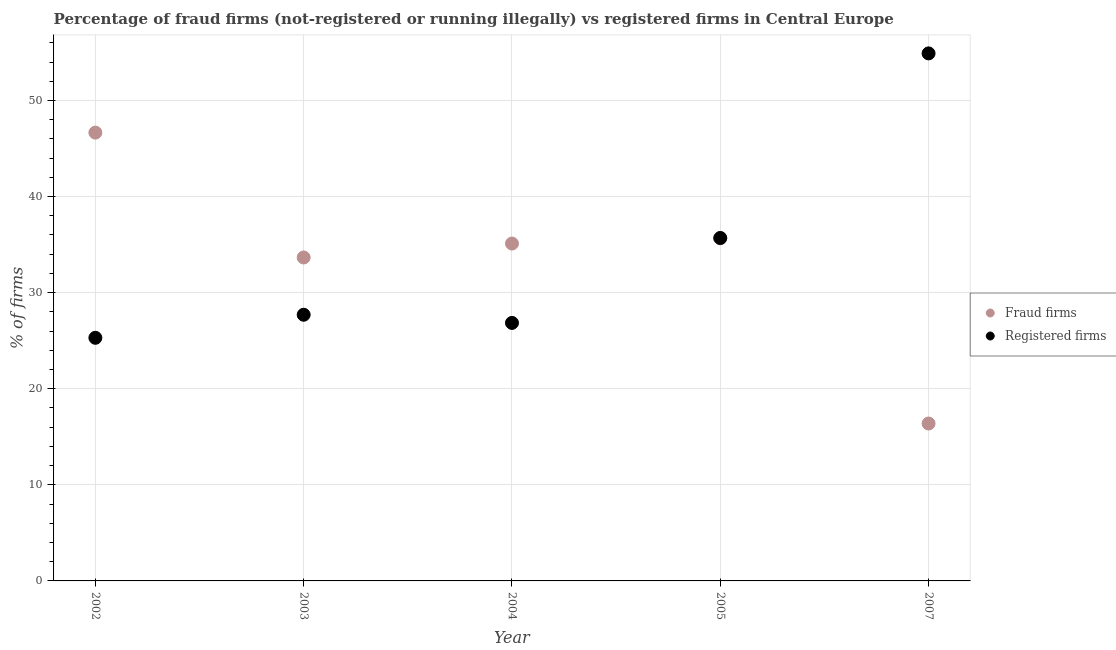What is the percentage of registered firms in 2004?
Keep it short and to the point. 26.85. Across all years, what is the maximum percentage of fraud firms?
Your answer should be very brief. 46.65. Across all years, what is the minimum percentage of fraud firms?
Give a very brief answer. 16.38. What is the total percentage of registered firms in the graph?
Your answer should be very brief. 170.44. What is the difference between the percentage of registered firms in 2003 and that in 2005?
Keep it short and to the point. -7.99. What is the difference between the percentage of registered firms in 2004 and the percentage of fraud firms in 2005?
Provide a short and direct response. -8.81. What is the average percentage of fraud firms per year?
Make the answer very short. 33.49. In the year 2003, what is the difference between the percentage of registered firms and percentage of fraud firms?
Ensure brevity in your answer.  -5.96. In how many years, is the percentage of registered firms greater than 38 %?
Your answer should be compact. 1. What is the ratio of the percentage of registered firms in 2003 to that in 2004?
Offer a very short reply. 1.03. Is the difference between the percentage of fraud firms in 2004 and 2007 greater than the difference between the percentage of registered firms in 2004 and 2007?
Give a very brief answer. Yes. What is the difference between the highest and the second highest percentage of registered firms?
Offer a terse response. 19.21. What is the difference between the highest and the lowest percentage of registered firms?
Your answer should be very brief. 29.6. Is the sum of the percentage of fraud firms in 2003 and 2004 greater than the maximum percentage of registered firms across all years?
Offer a very short reply. Yes. How many years are there in the graph?
Offer a very short reply. 5. What is the difference between two consecutive major ticks on the Y-axis?
Ensure brevity in your answer.  10. Are the values on the major ticks of Y-axis written in scientific E-notation?
Make the answer very short. No. How many legend labels are there?
Your answer should be very brief. 2. How are the legend labels stacked?
Ensure brevity in your answer.  Vertical. What is the title of the graph?
Make the answer very short. Percentage of fraud firms (not-registered or running illegally) vs registered firms in Central Europe. Does "Merchandise exports" appear as one of the legend labels in the graph?
Your response must be concise. No. What is the label or title of the X-axis?
Make the answer very short. Year. What is the label or title of the Y-axis?
Provide a succinct answer. % of firms. What is the % of firms in Fraud firms in 2002?
Provide a short and direct response. 46.65. What is the % of firms in Registered firms in 2002?
Your response must be concise. 25.3. What is the % of firms in Fraud firms in 2003?
Your response must be concise. 33.66. What is the % of firms in Registered firms in 2003?
Provide a short and direct response. 27.7. What is the % of firms in Fraud firms in 2004?
Make the answer very short. 35.11. What is the % of firms of Registered firms in 2004?
Ensure brevity in your answer.  26.85. What is the % of firms in Fraud firms in 2005?
Provide a short and direct response. 35.66. What is the % of firms of Registered firms in 2005?
Offer a very short reply. 35.69. What is the % of firms in Fraud firms in 2007?
Your answer should be very brief. 16.38. What is the % of firms in Registered firms in 2007?
Offer a very short reply. 54.9. Across all years, what is the maximum % of firms in Fraud firms?
Ensure brevity in your answer.  46.65. Across all years, what is the maximum % of firms in Registered firms?
Offer a very short reply. 54.9. Across all years, what is the minimum % of firms of Fraud firms?
Provide a short and direct response. 16.38. Across all years, what is the minimum % of firms of Registered firms?
Provide a short and direct response. 25.3. What is the total % of firms of Fraud firms in the graph?
Keep it short and to the point. 167.46. What is the total % of firms of Registered firms in the graph?
Your answer should be compact. 170.44. What is the difference between the % of firms of Fraud firms in 2002 and that in 2003?
Your response must be concise. 12.99. What is the difference between the % of firms of Fraud firms in 2002 and that in 2004?
Give a very brief answer. 11.54. What is the difference between the % of firms of Registered firms in 2002 and that in 2004?
Make the answer very short. -1.55. What is the difference between the % of firms in Fraud firms in 2002 and that in 2005?
Give a very brief answer. 11. What is the difference between the % of firms of Registered firms in 2002 and that in 2005?
Provide a succinct answer. -10.39. What is the difference between the % of firms in Fraud firms in 2002 and that in 2007?
Provide a short and direct response. 30.27. What is the difference between the % of firms in Registered firms in 2002 and that in 2007?
Provide a short and direct response. -29.6. What is the difference between the % of firms in Fraud firms in 2003 and that in 2004?
Give a very brief answer. -1.45. What is the difference between the % of firms of Registered firms in 2003 and that in 2004?
Provide a short and direct response. 0.85. What is the difference between the % of firms in Fraud firms in 2003 and that in 2005?
Your response must be concise. -2. What is the difference between the % of firms in Registered firms in 2003 and that in 2005?
Ensure brevity in your answer.  -7.99. What is the difference between the % of firms in Fraud firms in 2003 and that in 2007?
Your response must be concise. 17.28. What is the difference between the % of firms of Registered firms in 2003 and that in 2007?
Give a very brief answer. -27.2. What is the difference between the % of firms in Fraud firms in 2004 and that in 2005?
Provide a short and direct response. -0.55. What is the difference between the % of firms in Registered firms in 2004 and that in 2005?
Give a very brief answer. -8.84. What is the difference between the % of firms of Fraud firms in 2004 and that in 2007?
Offer a very short reply. 18.73. What is the difference between the % of firms of Registered firms in 2004 and that in 2007?
Your answer should be very brief. -28.05. What is the difference between the % of firms of Fraud firms in 2005 and that in 2007?
Give a very brief answer. 19.28. What is the difference between the % of firms in Registered firms in 2005 and that in 2007?
Provide a succinct answer. -19.21. What is the difference between the % of firms in Fraud firms in 2002 and the % of firms in Registered firms in 2003?
Offer a very short reply. 18.95. What is the difference between the % of firms of Fraud firms in 2002 and the % of firms of Registered firms in 2004?
Give a very brief answer. 19.8. What is the difference between the % of firms in Fraud firms in 2002 and the % of firms in Registered firms in 2005?
Give a very brief answer. 10.96. What is the difference between the % of firms in Fraud firms in 2002 and the % of firms in Registered firms in 2007?
Keep it short and to the point. -8.25. What is the difference between the % of firms of Fraud firms in 2003 and the % of firms of Registered firms in 2004?
Provide a succinct answer. 6.81. What is the difference between the % of firms in Fraud firms in 2003 and the % of firms in Registered firms in 2005?
Your answer should be very brief. -2.03. What is the difference between the % of firms in Fraud firms in 2003 and the % of firms in Registered firms in 2007?
Give a very brief answer. -21.24. What is the difference between the % of firms in Fraud firms in 2004 and the % of firms in Registered firms in 2005?
Your answer should be very brief. -0.58. What is the difference between the % of firms in Fraud firms in 2004 and the % of firms in Registered firms in 2007?
Ensure brevity in your answer.  -19.79. What is the difference between the % of firms in Fraud firms in 2005 and the % of firms in Registered firms in 2007?
Your response must be concise. -19.24. What is the average % of firms in Fraud firms per year?
Make the answer very short. 33.49. What is the average % of firms of Registered firms per year?
Ensure brevity in your answer.  34.09. In the year 2002, what is the difference between the % of firms in Fraud firms and % of firms in Registered firms?
Keep it short and to the point. 21.35. In the year 2003, what is the difference between the % of firms of Fraud firms and % of firms of Registered firms?
Keep it short and to the point. 5.96. In the year 2004, what is the difference between the % of firms in Fraud firms and % of firms in Registered firms?
Ensure brevity in your answer.  8.26. In the year 2005, what is the difference between the % of firms of Fraud firms and % of firms of Registered firms?
Ensure brevity in your answer.  -0.03. In the year 2007, what is the difference between the % of firms in Fraud firms and % of firms in Registered firms?
Provide a short and direct response. -38.52. What is the ratio of the % of firms of Fraud firms in 2002 to that in 2003?
Offer a very short reply. 1.39. What is the ratio of the % of firms in Registered firms in 2002 to that in 2003?
Provide a succinct answer. 0.91. What is the ratio of the % of firms in Fraud firms in 2002 to that in 2004?
Make the answer very short. 1.33. What is the ratio of the % of firms in Registered firms in 2002 to that in 2004?
Your answer should be very brief. 0.94. What is the ratio of the % of firms of Fraud firms in 2002 to that in 2005?
Offer a very short reply. 1.31. What is the ratio of the % of firms in Registered firms in 2002 to that in 2005?
Your answer should be compact. 0.71. What is the ratio of the % of firms of Fraud firms in 2002 to that in 2007?
Give a very brief answer. 2.85. What is the ratio of the % of firms in Registered firms in 2002 to that in 2007?
Make the answer very short. 0.46. What is the ratio of the % of firms in Fraud firms in 2003 to that in 2004?
Your answer should be very brief. 0.96. What is the ratio of the % of firms of Registered firms in 2003 to that in 2004?
Your answer should be compact. 1.03. What is the ratio of the % of firms in Fraud firms in 2003 to that in 2005?
Your response must be concise. 0.94. What is the ratio of the % of firms of Registered firms in 2003 to that in 2005?
Make the answer very short. 0.78. What is the ratio of the % of firms in Fraud firms in 2003 to that in 2007?
Your answer should be compact. 2.05. What is the ratio of the % of firms in Registered firms in 2003 to that in 2007?
Your answer should be very brief. 0.5. What is the ratio of the % of firms in Fraud firms in 2004 to that in 2005?
Ensure brevity in your answer.  0.98. What is the ratio of the % of firms in Registered firms in 2004 to that in 2005?
Give a very brief answer. 0.75. What is the ratio of the % of firms in Fraud firms in 2004 to that in 2007?
Your response must be concise. 2.14. What is the ratio of the % of firms of Registered firms in 2004 to that in 2007?
Provide a succinct answer. 0.49. What is the ratio of the % of firms in Fraud firms in 2005 to that in 2007?
Your answer should be very brief. 2.18. What is the ratio of the % of firms of Registered firms in 2005 to that in 2007?
Keep it short and to the point. 0.65. What is the difference between the highest and the second highest % of firms of Fraud firms?
Give a very brief answer. 11. What is the difference between the highest and the second highest % of firms in Registered firms?
Your answer should be very brief. 19.21. What is the difference between the highest and the lowest % of firms of Fraud firms?
Make the answer very short. 30.27. What is the difference between the highest and the lowest % of firms of Registered firms?
Keep it short and to the point. 29.6. 